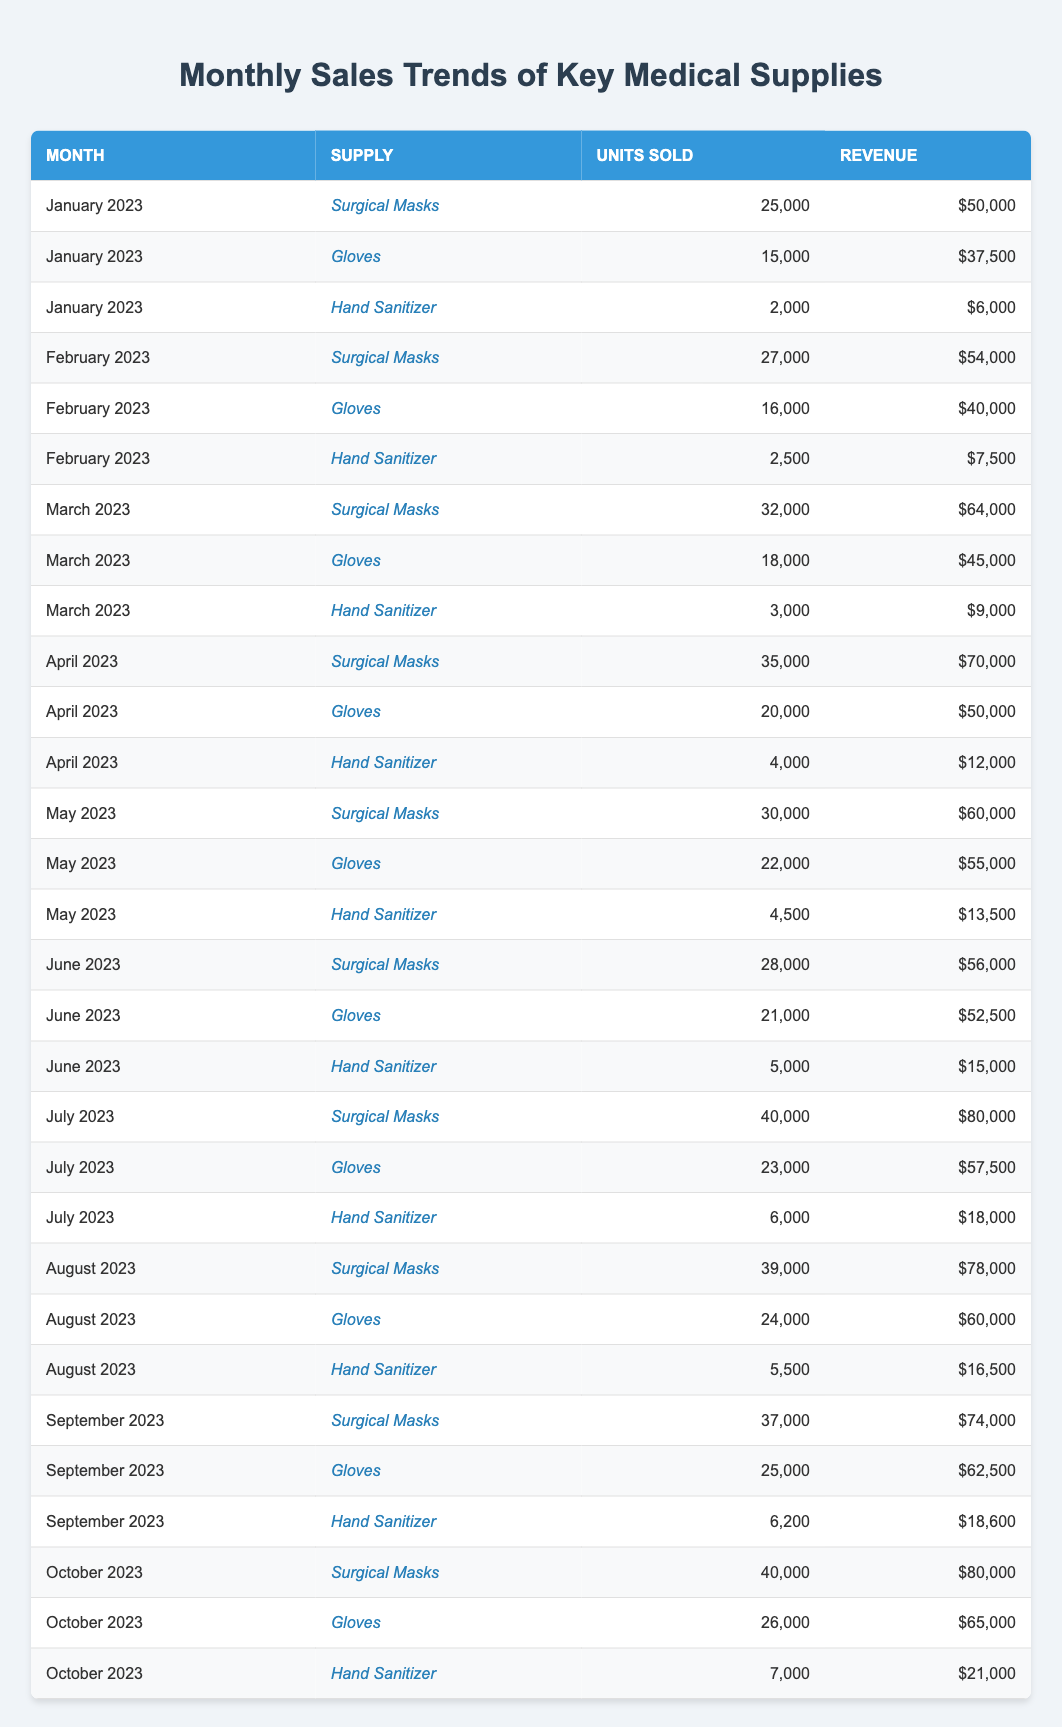What was the total revenue generated from Surgical Masks in March 2023? In March 2023, Surgical Masks generated a revenue of $64,000 as shown in the table.
Answer: $64,000 Which month had the highest sales in units for Gloves? By comparing the units sold for Gloves, July 2023 had the highest sales at 23,000 units.
Answer: July 2023 What was the average number of units sold for Hand Sanitizer over the past year? Adding the units sold for Hand Sanitizer for each month gives a total of 42,700 units across 10 months. To find the average, divide this by 10, resulting in an average of 4,270 units.
Answer: 4,270 Did the revenue for Surgical Masks increase every month? Observing the revenue for Surgical Masks, it increased from January to April but then fluctuated afterward, indicating it did not consistently increase each month.
Answer: No How much more revenue did Gloves generate in July 2023 compared to January 2023? The revenue from Gloves in July 2023 was $57,500, while in January 2023 it was $37,500. The difference is $57,500 - $37,500 = $20,000.
Answer: $20,000 What is the total number of units sold for all supplies in October 2023? The total number of units sold for all supplies in October is 40,000 (Surgical Masks) + 26,000 (Gloves) + 7,000 (Hand Sanitizer) = 73,000 units.
Answer: 73,000 What was the percentage increase in revenue from Hand Sanitizer from June 2023 to July 2023? The revenue for Hand Sanitizer in June 2023 was $15,000 and in July 2023 it was $18,000. The percentage increase is calculated as ((18,000 - 15,000) / 15,000) * 100 = 20%.
Answer: 20% Which supply had the lowest revenue in February 2023? The records show that Hand Sanitizer had the lowest revenue in February 2023, with a total of $7,500.
Answer: Hand Sanitizer What is the cumulative revenue for Gloves over the months from January to April 2023? Adding up the revenue for Gloves: $37,500 (Jan) + $40,000 (Feb) + $45,000 (Mar) + $50,000 (Apr) = $172,500.
Answer: $172,500 In which month did Hand Sanitizer have its highest units sold? Referring to the data, Hand Sanitizer had its highest units sold in July 2023, with 6,000 units sold.
Answer: July 2023 